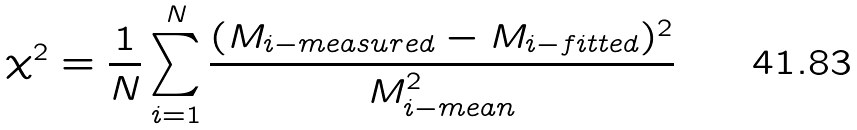<formula> <loc_0><loc_0><loc_500><loc_500>\chi ^ { 2 } = \frac { 1 } { N } \sum _ { i = 1 } ^ { N } \frac { ( M _ { i - m e a s u r e d } - M _ { i - f i t t e d } ) ^ { 2 } } { M _ { i - m e a n } ^ { 2 } }</formula> 